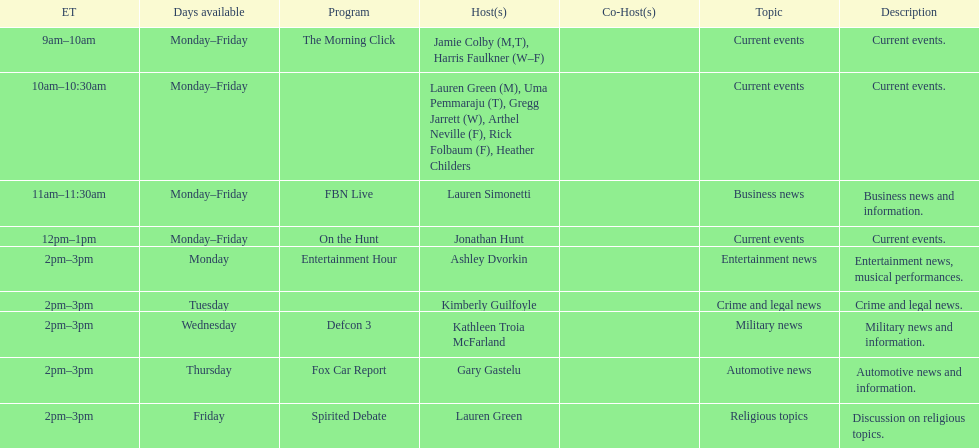Tell me the number of shows that only have one host per day. 7. 